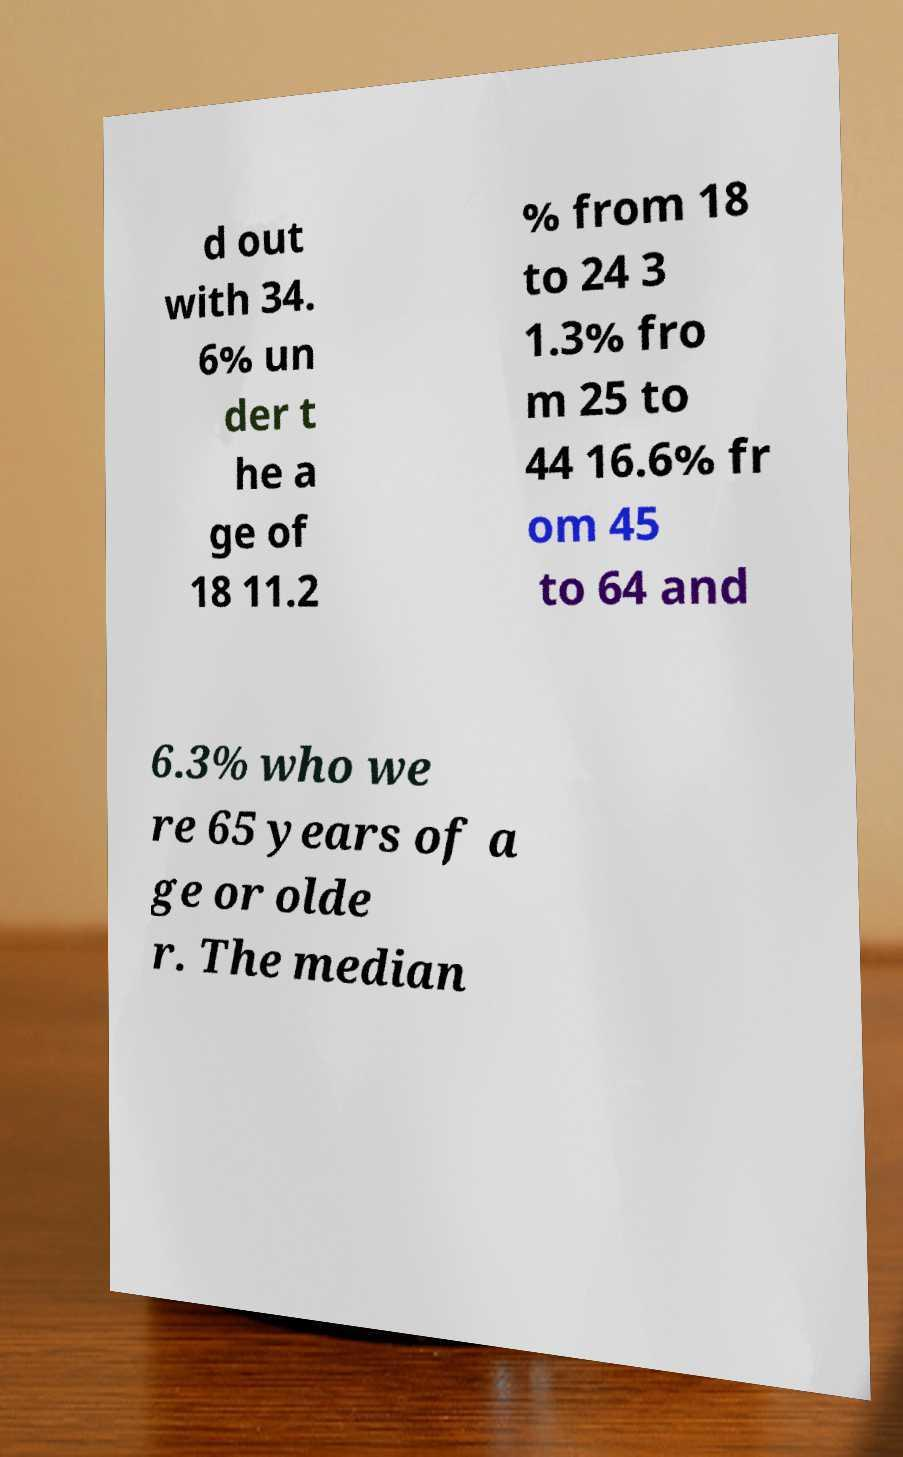Please read and relay the text visible in this image. What does it say? d out with 34. 6% un der t he a ge of 18 11.2 % from 18 to 24 3 1.3% fro m 25 to 44 16.6% fr om 45 to 64 and 6.3% who we re 65 years of a ge or olde r. The median 